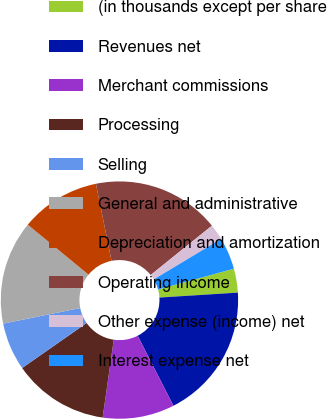<chart> <loc_0><loc_0><loc_500><loc_500><pie_chart><fcel>(in thousands except per share<fcel>Revenues net<fcel>Merchant commissions<fcel>Processing<fcel>Selling<fcel>General and administrative<fcel>Depreciation and amortization<fcel>Operating income<fcel>Other expense (income) net<fcel>Interest expense net<nl><fcel>3.26%<fcel>18.48%<fcel>9.78%<fcel>13.04%<fcel>6.52%<fcel>14.13%<fcel>10.87%<fcel>17.39%<fcel>2.17%<fcel>4.35%<nl></chart> 